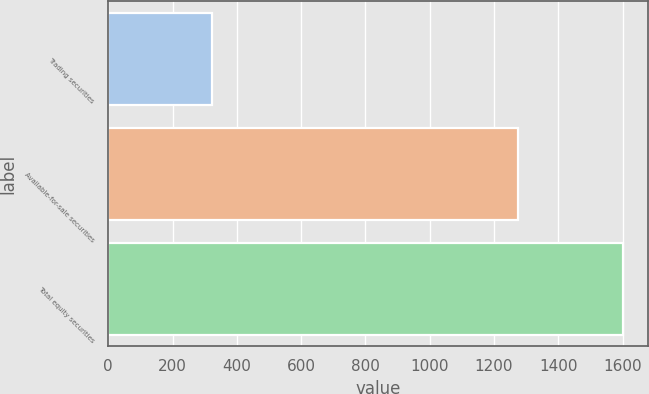Convert chart to OTSL. <chart><loc_0><loc_0><loc_500><loc_500><bar_chart><fcel>Trading securities<fcel>Available-for-sale securities<fcel>Total equity securities<nl><fcel>324<fcel>1276<fcel>1600<nl></chart> 